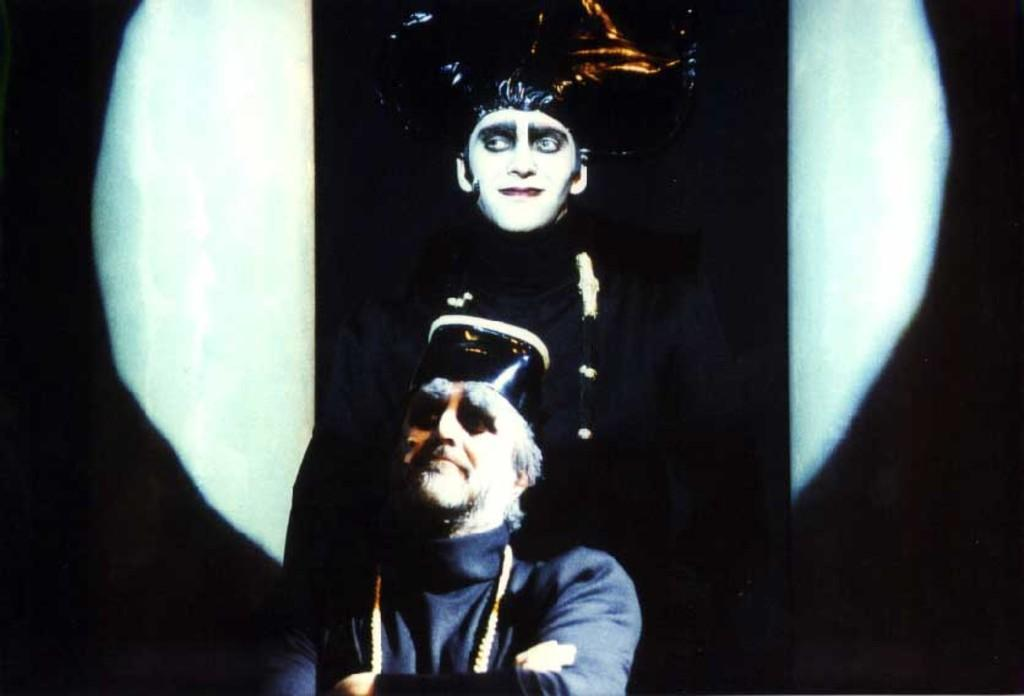How many people are present in the image? There are two men in the image. Can you describe the background of the image? The background of the image is white and black. What type of grain is being harvested by the men in the image? There is no indication of any grain or harvesting activity in the image; it only features two men. 